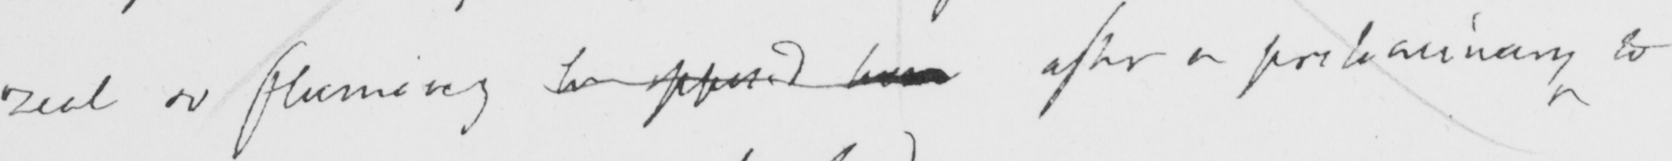What does this handwritten line say? zeal or  <gap/>  be opposed here after a preliminary to 